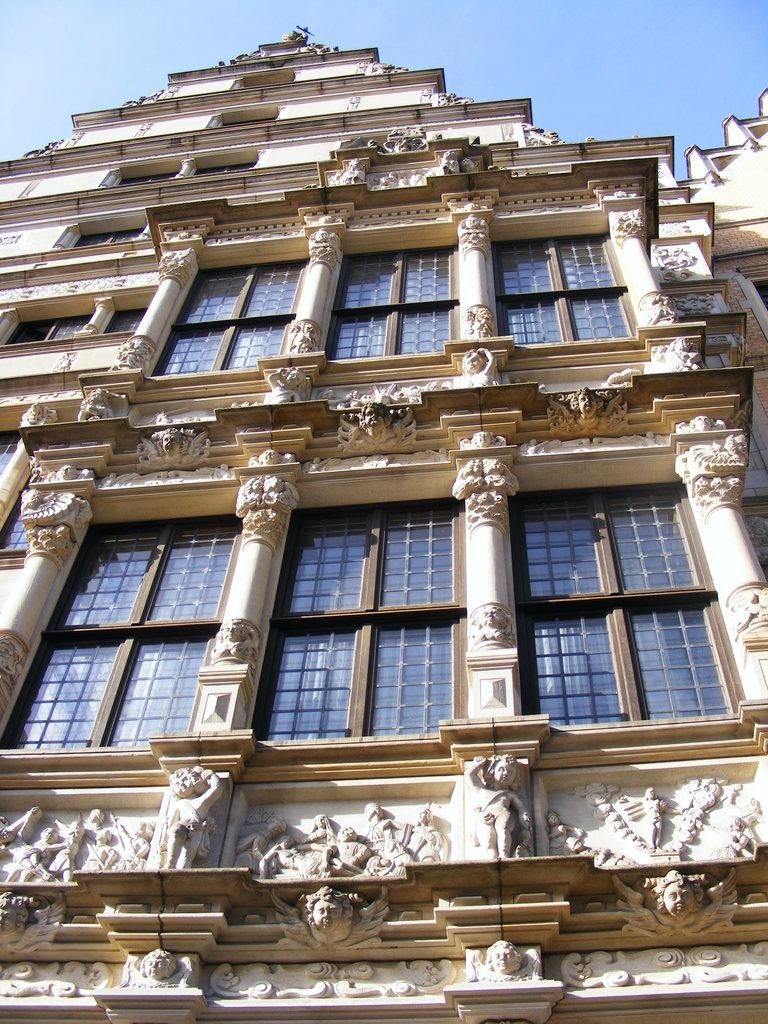What type of structure is in the image? There is a building in the image. What are some features of the building? The building has statues carved with stones and windows. What is visible at the top of the image? The sky is visible at the top of the image. Are there any masks hanging from the statues in the image? There is no mention of masks in the image; the statues are carved with stones. 